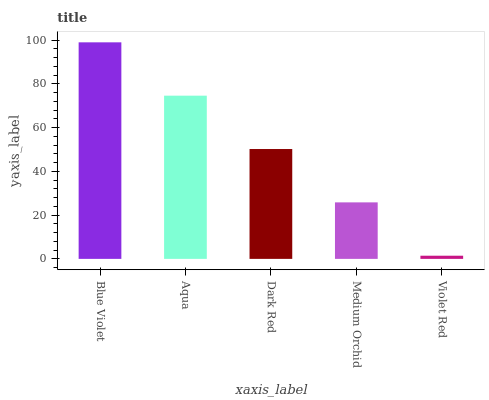Is Violet Red the minimum?
Answer yes or no. Yes. Is Blue Violet the maximum?
Answer yes or no. Yes. Is Aqua the minimum?
Answer yes or no. No. Is Aqua the maximum?
Answer yes or no. No. Is Blue Violet greater than Aqua?
Answer yes or no. Yes. Is Aqua less than Blue Violet?
Answer yes or no. Yes. Is Aqua greater than Blue Violet?
Answer yes or no. No. Is Blue Violet less than Aqua?
Answer yes or no. No. Is Dark Red the high median?
Answer yes or no. Yes. Is Dark Red the low median?
Answer yes or no. Yes. Is Blue Violet the high median?
Answer yes or no. No. Is Aqua the low median?
Answer yes or no. No. 